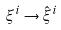<formula> <loc_0><loc_0><loc_500><loc_500>\xi ^ { i } \rightarrow \hat { \xi } ^ { i }</formula> 